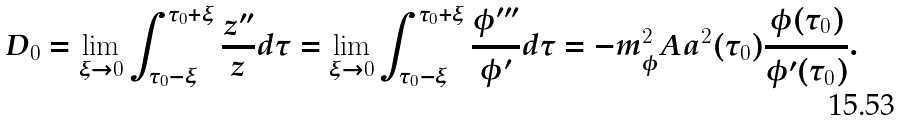Convert formula to latex. <formula><loc_0><loc_0><loc_500><loc_500>D _ { 0 } = \lim _ { \xi \rightarrow 0 } \int _ { \tau _ { 0 } - \xi } ^ { \tau _ { 0 } + \xi } \frac { z ^ { \prime \prime } } { z } d \tau = \lim _ { \xi \rightarrow 0 } \int _ { \tau _ { 0 } - \xi } ^ { \tau _ { 0 } + \xi } \frac { \phi ^ { \prime \prime \prime } } { \phi ^ { \prime } } d \tau = - m _ { \phi } ^ { 2 } A a ^ { 2 } ( \tau _ { 0 } ) \frac { \phi ( \tau _ { 0 } ) } { \phi ^ { \prime } ( \tau _ { 0 } ) } .</formula> 